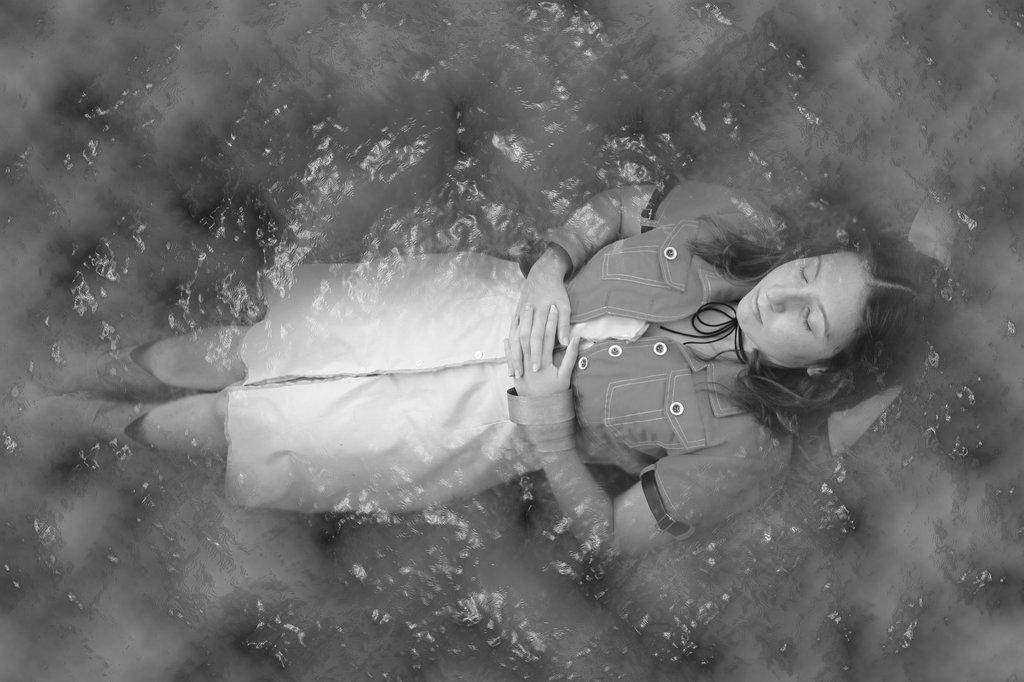What is the color scheme of the image? The image is black and white. Who is present in the image? There is a woman in the image. What is the woman wearing? The woman is wearing a shirt and skirt. What is the woman doing in the image? The woman is laying in the water. What type of car can be seen driving through the water in the image? There is no car present in the image; it features a woman laying in the water. How many bubbles are surrounding the woman in the image? There is no mention of bubbles in the image; it is a black and white image of a woman laying in the water. 